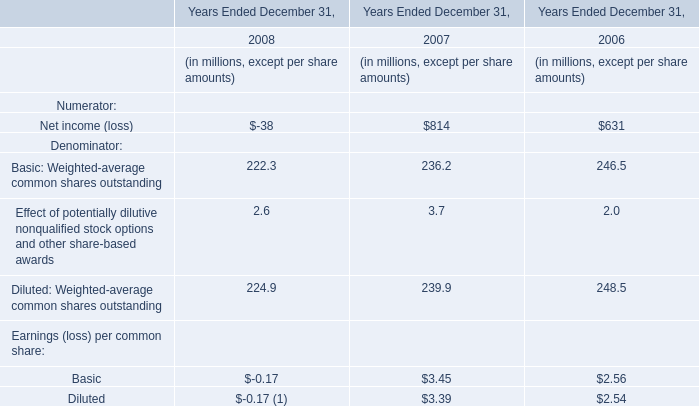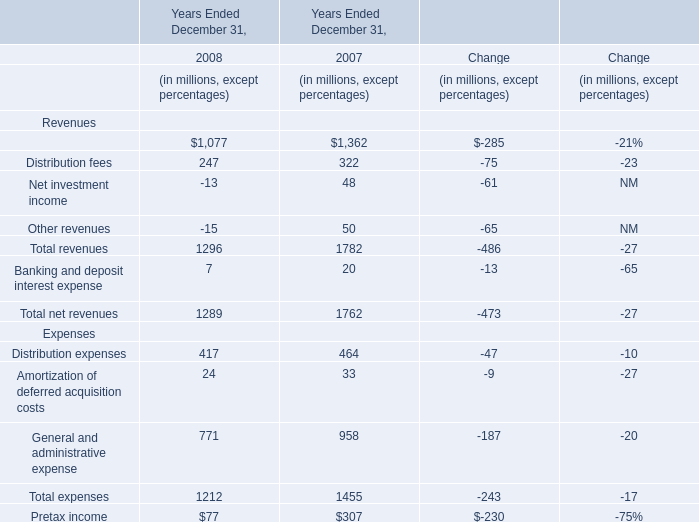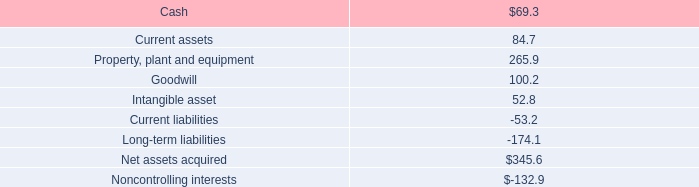in june 2010 , what was the implied total value of the joint venture metal beverage can plant in the prc , in $ million? 
Computations: (86.9 / (65 / 100))
Answer: 133.69231. 